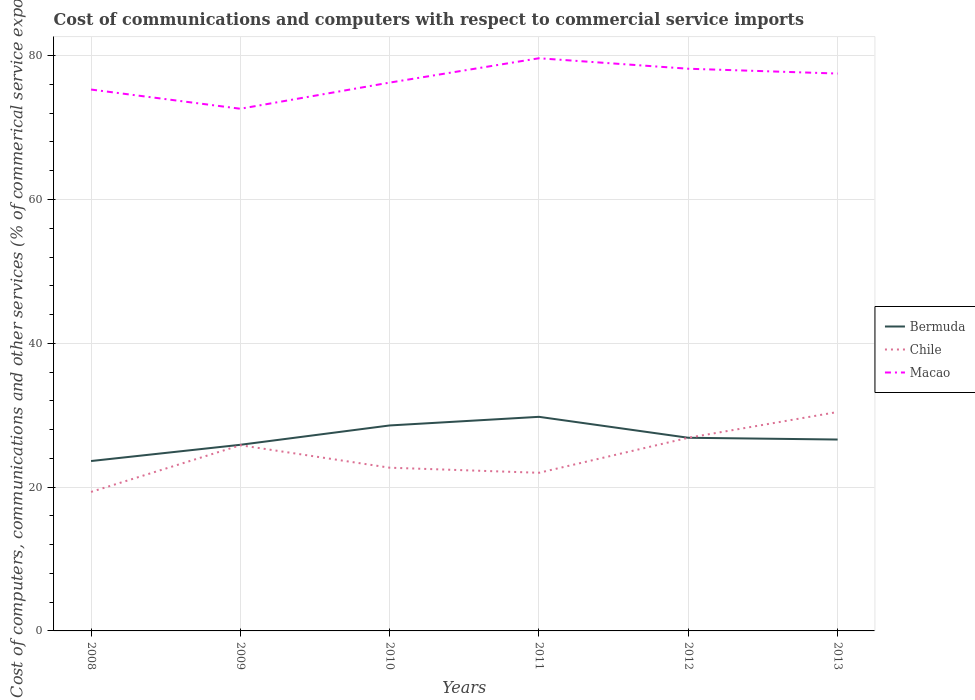How many different coloured lines are there?
Give a very brief answer. 3. Does the line corresponding to Chile intersect with the line corresponding to Bermuda?
Ensure brevity in your answer.  Yes. Is the number of lines equal to the number of legend labels?
Ensure brevity in your answer.  Yes. Across all years, what is the maximum cost of communications and computers in Chile?
Offer a very short reply. 19.33. What is the total cost of communications and computers in Chile in the graph?
Provide a succinct answer. -4.16. What is the difference between the highest and the second highest cost of communications and computers in Chile?
Your answer should be very brief. 11.12. What is the difference between the highest and the lowest cost of communications and computers in Macao?
Your answer should be compact. 3. How many lines are there?
Provide a succinct answer. 3. How many years are there in the graph?
Your answer should be very brief. 6. What is the difference between two consecutive major ticks on the Y-axis?
Offer a terse response. 20. Are the values on the major ticks of Y-axis written in scientific E-notation?
Make the answer very short. No. Does the graph contain any zero values?
Keep it short and to the point. No. How many legend labels are there?
Make the answer very short. 3. How are the legend labels stacked?
Keep it short and to the point. Vertical. What is the title of the graph?
Your answer should be compact. Cost of communications and computers with respect to commercial service imports. Does "Malta" appear as one of the legend labels in the graph?
Make the answer very short. No. What is the label or title of the Y-axis?
Your answer should be compact. Cost of computers, communications and other services (% of commerical service exports). What is the Cost of computers, communications and other services (% of commerical service exports) of Bermuda in 2008?
Your answer should be compact. 23.63. What is the Cost of computers, communications and other services (% of commerical service exports) in Chile in 2008?
Provide a succinct answer. 19.33. What is the Cost of computers, communications and other services (% of commerical service exports) of Macao in 2008?
Ensure brevity in your answer.  75.3. What is the Cost of computers, communications and other services (% of commerical service exports) in Bermuda in 2009?
Ensure brevity in your answer.  25.89. What is the Cost of computers, communications and other services (% of commerical service exports) of Chile in 2009?
Provide a succinct answer. 25.83. What is the Cost of computers, communications and other services (% of commerical service exports) in Macao in 2009?
Ensure brevity in your answer.  72.62. What is the Cost of computers, communications and other services (% of commerical service exports) in Bermuda in 2010?
Give a very brief answer. 28.58. What is the Cost of computers, communications and other services (% of commerical service exports) of Chile in 2010?
Ensure brevity in your answer.  22.7. What is the Cost of computers, communications and other services (% of commerical service exports) of Macao in 2010?
Give a very brief answer. 76.26. What is the Cost of computers, communications and other services (% of commerical service exports) in Bermuda in 2011?
Your answer should be compact. 29.78. What is the Cost of computers, communications and other services (% of commerical service exports) in Chile in 2011?
Offer a terse response. 21.99. What is the Cost of computers, communications and other services (% of commerical service exports) in Macao in 2011?
Your response must be concise. 79.65. What is the Cost of computers, communications and other services (% of commerical service exports) of Bermuda in 2012?
Ensure brevity in your answer.  26.86. What is the Cost of computers, communications and other services (% of commerical service exports) of Chile in 2012?
Your answer should be compact. 26.87. What is the Cost of computers, communications and other services (% of commerical service exports) of Macao in 2012?
Your answer should be very brief. 78.19. What is the Cost of computers, communications and other services (% of commerical service exports) in Bermuda in 2013?
Your answer should be very brief. 26.62. What is the Cost of computers, communications and other services (% of commerical service exports) of Chile in 2013?
Give a very brief answer. 30.45. What is the Cost of computers, communications and other services (% of commerical service exports) in Macao in 2013?
Make the answer very short. 77.52. Across all years, what is the maximum Cost of computers, communications and other services (% of commerical service exports) of Bermuda?
Give a very brief answer. 29.78. Across all years, what is the maximum Cost of computers, communications and other services (% of commerical service exports) in Chile?
Offer a terse response. 30.45. Across all years, what is the maximum Cost of computers, communications and other services (% of commerical service exports) of Macao?
Keep it short and to the point. 79.65. Across all years, what is the minimum Cost of computers, communications and other services (% of commerical service exports) of Bermuda?
Your answer should be compact. 23.63. Across all years, what is the minimum Cost of computers, communications and other services (% of commerical service exports) of Chile?
Give a very brief answer. 19.33. Across all years, what is the minimum Cost of computers, communications and other services (% of commerical service exports) in Macao?
Provide a succinct answer. 72.62. What is the total Cost of computers, communications and other services (% of commerical service exports) in Bermuda in the graph?
Ensure brevity in your answer.  161.35. What is the total Cost of computers, communications and other services (% of commerical service exports) in Chile in the graph?
Your response must be concise. 147.17. What is the total Cost of computers, communications and other services (% of commerical service exports) in Macao in the graph?
Offer a terse response. 459.53. What is the difference between the Cost of computers, communications and other services (% of commerical service exports) in Bermuda in 2008 and that in 2009?
Keep it short and to the point. -2.26. What is the difference between the Cost of computers, communications and other services (% of commerical service exports) in Chile in 2008 and that in 2009?
Your response must be concise. -6.49. What is the difference between the Cost of computers, communications and other services (% of commerical service exports) in Macao in 2008 and that in 2009?
Offer a very short reply. 2.67. What is the difference between the Cost of computers, communications and other services (% of commerical service exports) of Bermuda in 2008 and that in 2010?
Your response must be concise. -4.95. What is the difference between the Cost of computers, communications and other services (% of commerical service exports) of Chile in 2008 and that in 2010?
Give a very brief answer. -3.37. What is the difference between the Cost of computers, communications and other services (% of commerical service exports) of Macao in 2008 and that in 2010?
Offer a terse response. -0.96. What is the difference between the Cost of computers, communications and other services (% of commerical service exports) of Bermuda in 2008 and that in 2011?
Offer a very short reply. -6.15. What is the difference between the Cost of computers, communications and other services (% of commerical service exports) of Chile in 2008 and that in 2011?
Offer a very short reply. -2.66. What is the difference between the Cost of computers, communications and other services (% of commerical service exports) in Macao in 2008 and that in 2011?
Offer a very short reply. -4.35. What is the difference between the Cost of computers, communications and other services (% of commerical service exports) in Bermuda in 2008 and that in 2012?
Your answer should be compact. -3.24. What is the difference between the Cost of computers, communications and other services (% of commerical service exports) of Chile in 2008 and that in 2012?
Give a very brief answer. -7.53. What is the difference between the Cost of computers, communications and other services (% of commerical service exports) of Macao in 2008 and that in 2012?
Provide a succinct answer. -2.89. What is the difference between the Cost of computers, communications and other services (% of commerical service exports) in Bermuda in 2008 and that in 2013?
Keep it short and to the point. -2.99. What is the difference between the Cost of computers, communications and other services (% of commerical service exports) of Chile in 2008 and that in 2013?
Your answer should be very brief. -11.12. What is the difference between the Cost of computers, communications and other services (% of commerical service exports) of Macao in 2008 and that in 2013?
Your answer should be compact. -2.22. What is the difference between the Cost of computers, communications and other services (% of commerical service exports) of Bermuda in 2009 and that in 2010?
Give a very brief answer. -2.69. What is the difference between the Cost of computers, communications and other services (% of commerical service exports) in Chile in 2009 and that in 2010?
Give a very brief answer. 3.12. What is the difference between the Cost of computers, communications and other services (% of commerical service exports) of Macao in 2009 and that in 2010?
Make the answer very short. -3.64. What is the difference between the Cost of computers, communications and other services (% of commerical service exports) of Bermuda in 2009 and that in 2011?
Your answer should be compact. -3.89. What is the difference between the Cost of computers, communications and other services (% of commerical service exports) in Chile in 2009 and that in 2011?
Keep it short and to the point. 3.83. What is the difference between the Cost of computers, communications and other services (% of commerical service exports) of Macao in 2009 and that in 2011?
Provide a succinct answer. -7.02. What is the difference between the Cost of computers, communications and other services (% of commerical service exports) of Bermuda in 2009 and that in 2012?
Ensure brevity in your answer.  -0.98. What is the difference between the Cost of computers, communications and other services (% of commerical service exports) in Chile in 2009 and that in 2012?
Provide a short and direct response. -1.04. What is the difference between the Cost of computers, communications and other services (% of commerical service exports) of Macao in 2009 and that in 2012?
Give a very brief answer. -5.56. What is the difference between the Cost of computers, communications and other services (% of commerical service exports) of Bermuda in 2009 and that in 2013?
Offer a terse response. -0.73. What is the difference between the Cost of computers, communications and other services (% of commerical service exports) of Chile in 2009 and that in 2013?
Keep it short and to the point. -4.62. What is the difference between the Cost of computers, communications and other services (% of commerical service exports) in Macao in 2009 and that in 2013?
Your response must be concise. -4.9. What is the difference between the Cost of computers, communications and other services (% of commerical service exports) in Bermuda in 2010 and that in 2011?
Your answer should be very brief. -1.2. What is the difference between the Cost of computers, communications and other services (% of commerical service exports) of Chile in 2010 and that in 2011?
Provide a short and direct response. 0.71. What is the difference between the Cost of computers, communications and other services (% of commerical service exports) of Macao in 2010 and that in 2011?
Your response must be concise. -3.39. What is the difference between the Cost of computers, communications and other services (% of commerical service exports) in Bermuda in 2010 and that in 2012?
Give a very brief answer. 1.71. What is the difference between the Cost of computers, communications and other services (% of commerical service exports) of Chile in 2010 and that in 2012?
Ensure brevity in your answer.  -4.16. What is the difference between the Cost of computers, communications and other services (% of commerical service exports) in Macao in 2010 and that in 2012?
Offer a very short reply. -1.93. What is the difference between the Cost of computers, communications and other services (% of commerical service exports) in Bermuda in 2010 and that in 2013?
Make the answer very short. 1.96. What is the difference between the Cost of computers, communications and other services (% of commerical service exports) in Chile in 2010 and that in 2013?
Your answer should be very brief. -7.75. What is the difference between the Cost of computers, communications and other services (% of commerical service exports) of Macao in 2010 and that in 2013?
Offer a very short reply. -1.26. What is the difference between the Cost of computers, communications and other services (% of commerical service exports) in Bermuda in 2011 and that in 2012?
Keep it short and to the point. 2.91. What is the difference between the Cost of computers, communications and other services (% of commerical service exports) in Chile in 2011 and that in 2012?
Give a very brief answer. -4.87. What is the difference between the Cost of computers, communications and other services (% of commerical service exports) in Macao in 2011 and that in 2012?
Your answer should be compact. 1.46. What is the difference between the Cost of computers, communications and other services (% of commerical service exports) in Bermuda in 2011 and that in 2013?
Provide a succinct answer. 3.16. What is the difference between the Cost of computers, communications and other services (% of commerical service exports) in Chile in 2011 and that in 2013?
Your response must be concise. -8.45. What is the difference between the Cost of computers, communications and other services (% of commerical service exports) of Macao in 2011 and that in 2013?
Ensure brevity in your answer.  2.13. What is the difference between the Cost of computers, communications and other services (% of commerical service exports) in Bermuda in 2012 and that in 2013?
Offer a very short reply. 0.25. What is the difference between the Cost of computers, communications and other services (% of commerical service exports) of Chile in 2012 and that in 2013?
Give a very brief answer. -3.58. What is the difference between the Cost of computers, communications and other services (% of commerical service exports) of Macao in 2012 and that in 2013?
Your answer should be very brief. 0.67. What is the difference between the Cost of computers, communications and other services (% of commerical service exports) of Bermuda in 2008 and the Cost of computers, communications and other services (% of commerical service exports) of Chile in 2009?
Your answer should be compact. -2.2. What is the difference between the Cost of computers, communications and other services (% of commerical service exports) in Bermuda in 2008 and the Cost of computers, communications and other services (% of commerical service exports) in Macao in 2009?
Keep it short and to the point. -49. What is the difference between the Cost of computers, communications and other services (% of commerical service exports) of Chile in 2008 and the Cost of computers, communications and other services (% of commerical service exports) of Macao in 2009?
Offer a terse response. -53.29. What is the difference between the Cost of computers, communications and other services (% of commerical service exports) in Bermuda in 2008 and the Cost of computers, communications and other services (% of commerical service exports) in Chile in 2010?
Keep it short and to the point. 0.93. What is the difference between the Cost of computers, communications and other services (% of commerical service exports) in Bermuda in 2008 and the Cost of computers, communications and other services (% of commerical service exports) in Macao in 2010?
Keep it short and to the point. -52.63. What is the difference between the Cost of computers, communications and other services (% of commerical service exports) of Chile in 2008 and the Cost of computers, communications and other services (% of commerical service exports) of Macao in 2010?
Provide a short and direct response. -56.93. What is the difference between the Cost of computers, communications and other services (% of commerical service exports) in Bermuda in 2008 and the Cost of computers, communications and other services (% of commerical service exports) in Chile in 2011?
Offer a very short reply. 1.63. What is the difference between the Cost of computers, communications and other services (% of commerical service exports) of Bermuda in 2008 and the Cost of computers, communications and other services (% of commerical service exports) of Macao in 2011?
Your response must be concise. -56.02. What is the difference between the Cost of computers, communications and other services (% of commerical service exports) of Chile in 2008 and the Cost of computers, communications and other services (% of commerical service exports) of Macao in 2011?
Ensure brevity in your answer.  -60.31. What is the difference between the Cost of computers, communications and other services (% of commerical service exports) of Bermuda in 2008 and the Cost of computers, communications and other services (% of commerical service exports) of Chile in 2012?
Provide a short and direct response. -3.24. What is the difference between the Cost of computers, communications and other services (% of commerical service exports) in Bermuda in 2008 and the Cost of computers, communications and other services (% of commerical service exports) in Macao in 2012?
Offer a terse response. -54.56. What is the difference between the Cost of computers, communications and other services (% of commerical service exports) in Chile in 2008 and the Cost of computers, communications and other services (% of commerical service exports) in Macao in 2012?
Give a very brief answer. -58.86. What is the difference between the Cost of computers, communications and other services (% of commerical service exports) in Bermuda in 2008 and the Cost of computers, communications and other services (% of commerical service exports) in Chile in 2013?
Your answer should be very brief. -6.82. What is the difference between the Cost of computers, communications and other services (% of commerical service exports) in Bermuda in 2008 and the Cost of computers, communications and other services (% of commerical service exports) in Macao in 2013?
Make the answer very short. -53.89. What is the difference between the Cost of computers, communications and other services (% of commerical service exports) of Chile in 2008 and the Cost of computers, communications and other services (% of commerical service exports) of Macao in 2013?
Keep it short and to the point. -58.19. What is the difference between the Cost of computers, communications and other services (% of commerical service exports) of Bermuda in 2009 and the Cost of computers, communications and other services (% of commerical service exports) of Chile in 2010?
Your answer should be compact. 3.19. What is the difference between the Cost of computers, communications and other services (% of commerical service exports) in Bermuda in 2009 and the Cost of computers, communications and other services (% of commerical service exports) in Macao in 2010?
Make the answer very short. -50.37. What is the difference between the Cost of computers, communications and other services (% of commerical service exports) of Chile in 2009 and the Cost of computers, communications and other services (% of commerical service exports) of Macao in 2010?
Provide a succinct answer. -50.43. What is the difference between the Cost of computers, communications and other services (% of commerical service exports) of Bermuda in 2009 and the Cost of computers, communications and other services (% of commerical service exports) of Chile in 2011?
Provide a short and direct response. 3.89. What is the difference between the Cost of computers, communications and other services (% of commerical service exports) in Bermuda in 2009 and the Cost of computers, communications and other services (% of commerical service exports) in Macao in 2011?
Keep it short and to the point. -53.76. What is the difference between the Cost of computers, communications and other services (% of commerical service exports) of Chile in 2009 and the Cost of computers, communications and other services (% of commerical service exports) of Macao in 2011?
Your answer should be very brief. -53.82. What is the difference between the Cost of computers, communications and other services (% of commerical service exports) of Bermuda in 2009 and the Cost of computers, communications and other services (% of commerical service exports) of Chile in 2012?
Keep it short and to the point. -0.98. What is the difference between the Cost of computers, communications and other services (% of commerical service exports) in Bermuda in 2009 and the Cost of computers, communications and other services (% of commerical service exports) in Macao in 2012?
Your answer should be very brief. -52.3. What is the difference between the Cost of computers, communications and other services (% of commerical service exports) in Chile in 2009 and the Cost of computers, communications and other services (% of commerical service exports) in Macao in 2012?
Offer a terse response. -52.36. What is the difference between the Cost of computers, communications and other services (% of commerical service exports) in Bermuda in 2009 and the Cost of computers, communications and other services (% of commerical service exports) in Chile in 2013?
Give a very brief answer. -4.56. What is the difference between the Cost of computers, communications and other services (% of commerical service exports) of Bermuda in 2009 and the Cost of computers, communications and other services (% of commerical service exports) of Macao in 2013?
Your answer should be very brief. -51.63. What is the difference between the Cost of computers, communications and other services (% of commerical service exports) in Chile in 2009 and the Cost of computers, communications and other services (% of commerical service exports) in Macao in 2013?
Ensure brevity in your answer.  -51.69. What is the difference between the Cost of computers, communications and other services (% of commerical service exports) in Bermuda in 2010 and the Cost of computers, communications and other services (% of commerical service exports) in Chile in 2011?
Provide a short and direct response. 6.58. What is the difference between the Cost of computers, communications and other services (% of commerical service exports) in Bermuda in 2010 and the Cost of computers, communications and other services (% of commerical service exports) in Macao in 2011?
Make the answer very short. -51.07. What is the difference between the Cost of computers, communications and other services (% of commerical service exports) in Chile in 2010 and the Cost of computers, communications and other services (% of commerical service exports) in Macao in 2011?
Make the answer very short. -56.94. What is the difference between the Cost of computers, communications and other services (% of commerical service exports) of Bermuda in 2010 and the Cost of computers, communications and other services (% of commerical service exports) of Chile in 2012?
Your answer should be very brief. 1.71. What is the difference between the Cost of computers, communications and other services (% of commerical service exports) of Bermuda in 2010 and the Cost of computers, communications and other services (% of commerical service exports) of Macao in 2012?
Keep it short and to the point. -49.61. What is the difference between the Cost of computers, communications and other services (% of commerical service exports) in Chile in 2010 and the Cost of computers, communications and other services (% of commerical service exports) in Macao in 2012?
Make the answer very short. -55.49. What is the difference between the Cost of computers, communications and other services (% of commerical service exports) of Bermuda in 2010 and the Cost of computers, communications and other services (% of commerical service exports) of Chile in 2013?
Provide a short and direct response. -1.87. What is the difference between the Cost of computers, communications and other services (% of commerical service exports) of Bermuda in 2010 and the Cost of computers, communications and other services (% of commerical service exports) of Macao in 2013?
Provide a succinct answer. -48.94. What is the difference between the Cost of computers, communications and other services (% of commerical service exports) in Chile in 2010 and the Cost of computers, communications and other services (% of commerical service exports) in Macao in 2013?
Keep it short and to the point. -54.82. What is the difference between the Cost of computers, communications and other services (% of commerical service exports) in Bermuda in 2011 and the Cost of computers, communications and other services (% of commerical service exports) in Chile in 2012?
Give a very brief answer. 2.91. What is the difference between the Cost of computers, communications and other services (% of commerical service exports) of Bermuda in 2011 and the Cost of computers, communications and other services (% of commerical service exports) of Macao in 2012?
Offer a terse response. -48.41. What is the difference between the Cost of computers, communications and other services (% of commerical service exports) of Chile in 2011 and the Cost of computers, communications and other services (% of commerical service exports) of Macao in 2012?
Offer a very short reply. -56.19. What is the difference between the Cost of computers, communications and other services (% of commerical service exports) of Bermuda in 2011 and the Cost of computers, communications and other services (% of commerical service exports) of Chile in 2013?
Provide a short and direct response. -0.67. What is the difference between the Cost of computers, communications and other services (% of commerical service exports) in Bermuda in 2011 and the Cost of computers, communications and other services (% of commerical service exports) in Macao in 2013?
Offer a terse response. -47.74. What is the difference between the Cost of computers, communications and other services (% of commerical service exports) in Chile in 2011 and the Cost of computers, communications and other services (% of commerical service exports) in Macao in 2013?
Keep it short and to the point. -55.53. What is the difference between the Cost of computers, communications and other services (% of commerical service exports) of Bermuda in 2012 and the Cost of computers, communications and other services (% of commerical service exports) of Chile in 2013?
Your response must be concise. -3.59. What is the difference between the Cost of computers, communications and other services (% of commerical service exports) of Bermuda in 2012 and the Cost of computers, communications and other services (% of commerical service exports) of Macao in 2013?
Offer a very short reply. -50.66. What is the difference between the Cost of computers, communications and other services (% of commerical service exports) in Chile in 2012 and the Cost of computers, communications and other services (% of commerical service exports) in Macao in 2013?
Your response must be concise. -50.65. What is the average Cost of computers, communications and other services (% of commerical service exports) in Bermuda per year?
Ensure brevity in your answer.  26.89. What is the average Cost of computers, communications and other services (% of commerical service exports) in Chile per year?
Give a very brief answer. 24.53. What is the average Cost of computers, communications and other services (% of commerical service exports) of Macao per year?
Your response must be concise. 76.59. In the year 2008, what is the difference between the Cost of computers, communications and other services (% of commerical service exports) of Bermuda and Cost of computers, communications and other services (% of commerical service exports) of Chile?
Your answer should be very brief. 4.29. In the year 2008, what is the difference between the Cost of computers, communications and other services (% of commerical service exports) of Bermuda and Cost of computers, communications and other services (% of commerical service exports) of Macao?
Provide a succinct answer. -51.67. In the year 2008, what is the difference between the Cost of computers, communications and other services (% of commerical service exports) of Chile and Cost of computers, communications and other services (% of commerical service exports) of Macao?
Ensure brevity in your answer.  -55.96. In the year 2009, what is the difference between the Cost of computers, communications and other services (% of commerical service exports) in Bermuda and Cost of computers, communications and other services (% of commerical service exports) in Chile?
Ensure brevity in your answer.  0.06. In the year 2009, what is the difference between the Cost of computers, communications and other services (% of commerical service exports) in Bermuda and Cost of computers, communications and other services (% of commerical service exports) in Macao?
Offer a very short reply. -46.74. In the year 2009, what is the difference between the Cost of computers, communications and other services (% of commerical service exports) in Chile and Cost of computers, communications and other services (% of commerical service exports) in Macao?
Provide a short and direct response. -46.8. In the year 2010, what is the difference between the Cost of computers, communications and other services (% of commerical service exports) of Bermuda and Cost of computers, communications and other services (% of commerical service exports) of Chile?
Provide a short and direct response. 5.88. In the year 2010, what is the difference between the Cost of computers, communications and other services (% of commerical service exports) in Bermuda and Cost of computers, communications and other services (% of commerical service exports) in Macao?
Keep it short and to the point. -47.68. In the year 2010, what is the difference between the Cost of computers, communications and other services (% of commerical service exports) of Chile and Cost of computers, communications and other services (% of commerical service exports) of Macao?
Offer a very short reply. -53.56. In the year 2011, what is the difference between the Cost of computers, communications and other services (% of commerical service exports) of Bermuda and Cost of computers, communications and other services (% of commerical service exports) of Chile?
Your answer should be compact. 7.78. In the year 2011, what is the difference between the Cost of computers, communications and other services (% of commerical service exports) of Bermuda and Cost of computers, communications and other services (% of commerical service exports) of Macao?
Give a very brief answer. -49.87. In the year 2011, what is the difference between the Cost of computers, communications and other services (% of commerical service exports) in Chile and Cost of computers, communications and other services (% of commerical service exports) in Macao?
Your response must be concise. -57.65. In the year 2012, what is the difference between the Cost of computers, communications and other services (% of commerical service exports) in Bermuda and Cost of computers, communications and other services (% of commerical service exports) in Chile?
Ensure brevity in your answer.  -0. In the year 2012, what is the difference between the Cost of computers, communications and other services (% of commerical service exports) in Bermuda and Cost of computers, communications and other services (% of commerical service exports) in Macao?
Keep it short and to the point. -51.33. In the year 2012, what is the difference between the Cost of computers, communications and other services (% of commerical service exports) of Chile and Cost of computers, communications and other services (% of commerical service exports) of Macao?
Make the answer very short. -51.32. In the year 2013, what is the difference between the Cost of computers, communications and other services (% of commerical service exports) in Bermuda and Cost of computers, communications and other services (% of commerical service exports) in Chile?
Offer a very short reply. -3.83. In the year 2013, what is the difference between the Cost of computers, communications and other services (% of commerical service exports) in Bermuda and Cost of computers, communications and other services (% of commerical service exports) in Macao?
Give a very brief answer. -50.9. In the year 2013, what is the difference between the Cost of computers, communications and other services (% of commerical service exports) in Chile and Cost of computers, communications and other services (% of commerical service exports) in Macao?
Offer a very short reply. -47.07. What is the ratio of the Cost of computers, communications and other services (% of commerical service exports) of Bermuda in 2008 to that in 2009?
Offer a very short reply. 0.91. What is the ratio of the Cost of computers, communications and other services (% of commerical service exports) in Chile in 2008 to that in 2009?
Offer a terse response. 0.75. What is the ratio of the Cost of computers, communications and other services (% of commerical service exports) of Macao in 2008 to that in 2009?
Keep it short and to the point. 1.04. What is the ratio of the Cost of computers, communications and other services (% of commerical service exports) of Bermuda in 2008 to that in 2010?
Offer a very short reply. 0.83. What is the ratio of the Cost of computers, communications and other services (% of commerical service exports) of Chile in 2008 to that in 2010?
Offer a terse response. 0.85. What is the ratio of the Cost of computers, communications and other services (% of commerical service exports) in Macao in 2008 to that in 2010?
Your answer should be very brief. 0.99. What is the ratio of the Cost of computers, communications and other services (% of commerical service exports) in Bermuda in 2008 to that in 2011?
Your answer should be very brief. 0.79. What is the ratio of the Cost of computers, communications and other services (% of commerical service exports) in Chile in 2008 to that in 2011?
Make the answer very short. 0.88. What is the ratio of the Cost of computers, communications and other services (% of commerical service exports) in Macao in 2008 to that in 2011?
Your response must be concise. 0.95. What is the ratio of the Cost of computers, communications and other services (% of commerical service exports) in Bermuda in 2008 to that in 2012?
Give a very brief answer. 0.88. What is the ratio of the Cost of computers, communications and other services (% of commerical service exports) in Chile in 2008 to that in 2012?
Your response must be concise. 0.72. What is the ratio of the Cost of computers, communications and other services (% of commerical service exports) in Macao in 2008 to that in 2012?
Offer a terse response. 0.96. What is the ratio of the Cost of computers, communications and other services (% of commerical service exports) in Bermuda in 2008 to that in 2013?
Your response must be concise. 0.89. What is the ratio of the Cost of computers, communications and other services (% of commerical service exports) of Chile in 2008 to that in 2013?
Provide a succinct answer. 0.63. What is the ratio of the Cost of computers, communications and other services (% of commerical service exports) of Macao in 2008 to that in 2013?
Make the answer very short. 0.97. What is the ratio of the Cost of computers, communications and other services (% of commerical service exports) of Bermuda in 2009 to that in 2010?
Your answer should be compact. 0.91. What is the ratio of the Cost of computers, communications and other services (% of commerical service exports) in Chile in 2009 to that in 2010?
Keep it short and to the point. 1.14. What is the ratio of the Cost of computers, communications and other services (% of commerical service exports) of Macao in 2009 to that in 2010?
Ensure brevity in your answer.  0.95. What is the ratio of the Cost of computers, communications and other services (% of commerical service exports) in Bermuda in 2009 to that in 2011?
Provide a succinct answer. 0.87. What is the ratio of the Cost of computers, communications and other services (% of commerical service exports) in Chile in 2009 to that in 2011?
Your response must be concise. 1.17. What is the ratio of the Cost of computers, communications and other services (% of commerical service exports) of Macao in 2009 to that in 2011?
Keep it short and to the point. 0.91. What is the ratio of the Cost of computers, communications and other services (% of commerical service exports) of Bermuda in 2009 to that in 2012?
Ensure brevity in your answer.  0.96. What is the ratio of the Cost of computers, communications and other services (% of commerical service exports) in Chile in 2009 to that in 2012?
Offer a terse response. 0.96. What is the ratio of the Cost of computers, communications and other services (% of commerical service exports) of Macao in 2009 to that in 2012?
Your answer should be compact. 0.93. What is the ratio of the Cost of computers, communications and other services (% of commerical service exports) in Bermuda in 2009 to that in 2013?
Make the answer very short. 0.97. What is the ratio of the Cost of computers, communications and other services (% of commerical service exports) of Chile in 2009 to that in 2013?
Offer a terse response. 0.85. What is the ratio of the Cost of computers, communications and other services (% of commerical service exports) of Macao in 2009 to that in 2013?
Ensure brevity in your answer.  0.94. What is the ratio of the Cost of computers, communications and other services (% of commerical service exports) of Bermuda in 2010 to that in 2011?
Give a very brief answer. 0.96. What is the ratio of the Cost of computers, communications and other services (% of commerical service exports) of Chile in 2010 to that in 2011?
Offer a very short reply. 1.03. What is the ratio of the Cost of computers, communications and other services (% of commerical service exports) in Macao in 2010 to that in 2011?
Your response must be concise. 0.96. What is the ratio of the Cost of computers, communications and other services (% of commerical service exports) in Bermuda in 2010 to that in 2012?
Ensure brevity in your answer.  1.06. What is the ratio of the Cost of computers, communications and other services (% of commerical service exports) of Chile in 2010 to that in 2012?
Provide a succinct answer. 0.84. What is the ratio of the Cost of computers, communications and other services (% of commerical service exports) of Macao in 2010 to that in 2012?
Your answer should be compact. 0.98. What is the ratio of the Cost of computers, communications and other services (% of commerical service exports) of Bermuda in 2010 to that in 2013?
Ensure brevity in your answer.  1.07. What is the ratio of the Cost of computers, communications and other services (% of commerical service exports) of Chile in 2010 to that in 2013?
Ensure brevity in your answer.  0.75. What is the ratio of the Cost of computers, communications and other services (% of commerical service exports) in Macao in 2010 to that in 2013?
Your response must be concise. 0.98. What is the ratio of the Cost of computers, communications and other services (% of commerical service exports) in Bermuda in 2011 to that in 2012?
Provide a succinct answer. 1.11. What is the ratio of the Cost of computers, communications and other services (% of commerical service exports) in Chile in 2011 to that in 2012?
Your response must be concise. 0.82. What is the ratio of the Cost of computers, communications and other services (% of commerical service exports) of Macao in 2011 to that in 2012?
Offer a very short reply. 1.02. What is the ratio of the Cost of computers, communications and other services (% of commerical service exports) of Bermuda in 2011 to that in 2013?
Your answer should be very brief. 1.12. What is the ratio of the Cost of computers, communications and other services (% of commerical service exports) of Chile in 2011 to that in 2013?
Provide a succinct answer. 0.72. What is the ratio of the Cost of computers, communications and other services (% of commerical service exports) in Macao in 2011 to that in 2013?
Offer a very short reply. 1.03. What is the ratio of the Cost of computers, communications and other services (% of commerical service exports) in Bermuda in 2012 to that in 2013?
Your answer should be very brief. 1.01. What is the ratio of the Cost of computers, communications and other services (% of commerical service exports) of Chile in 2012 to that in 2013?
Ensure brevity in your answer.  0.88. What is the ratio of the Cost of computers, communications and other services (% of commerical service exports) of Macao in 2012 to that in 2013?
Your answer should be very brief. 1.01. What is the difference between the highest and the second highest Cost of computers, communications and other services (% of commerical service exports) in Bermuda?
Offer a terse response. 1.2. What is the difference between the highest and the second highest Cost of computers, communications and other services (% of commerical service exports) in Chile?
Ensure brevity in your answer.  3.58. What is the difference between the highest and the second highest Cost of computers, communications and other services (% of commerical service exports) of Macao?
Offer a terse response. 1.46. What is the difference between the highest and the lowest Cost of computers, communications and other services (% of commerical service exports) in Bermuda?
Your response must be concise. 6.15. What is the difference between the highest and the lowest Cost of computers, communications and other services (% of commerical service exports) in Chile?
Your answer should be compact. 11.12. What is the difference between the highest and the lowest Cost of computers, communications and other services (% of commerical service exports) in Macao?
Give a very brief answer. 7.02. 